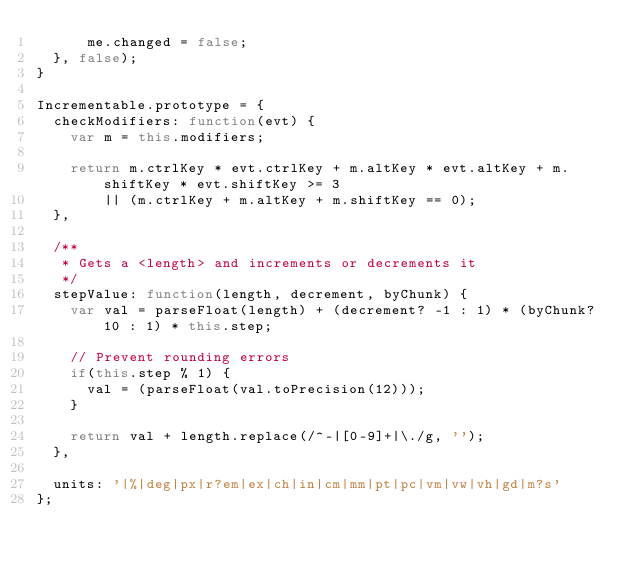<code> <loc_0><loc_0><loc_500><loc_500><_JavaScript_>			me.changed = false;
	}, false);
}

Incrementable.prototype = {
	checkModifiers: function(evt) {
		var m = this.modifiers;

		return m.ctrlKey * evt.ctrlKey + m.altKey * evt.altKey + m.shiftKey * evt.shiftKey >= 3
				|| (m.ctrlKey + m.altKey + m.shiftKey == 0);
	},
	
	/**
	 * Gets a <length> and increments or decrements it
	 */
	stepValue: function(length, decrement, byChunk) {
		var val = parseFloat(length) + (decrement? -1 : 1) * (byChunk? 10 : 1) * this.step;
		
		// Prevent rounding errors
		if(this.step % 1) {
			val = (parseFloat(val.toPrecision(12)));
		}
		
		return val + length.replace(/^-|[0-9]+|\./g, '');
	},

	units: '|%|deg|px|r?em|ex|ch|in|cm|mm|pt|pc|vm|vw|vh|gd|m?s'
};</code> 